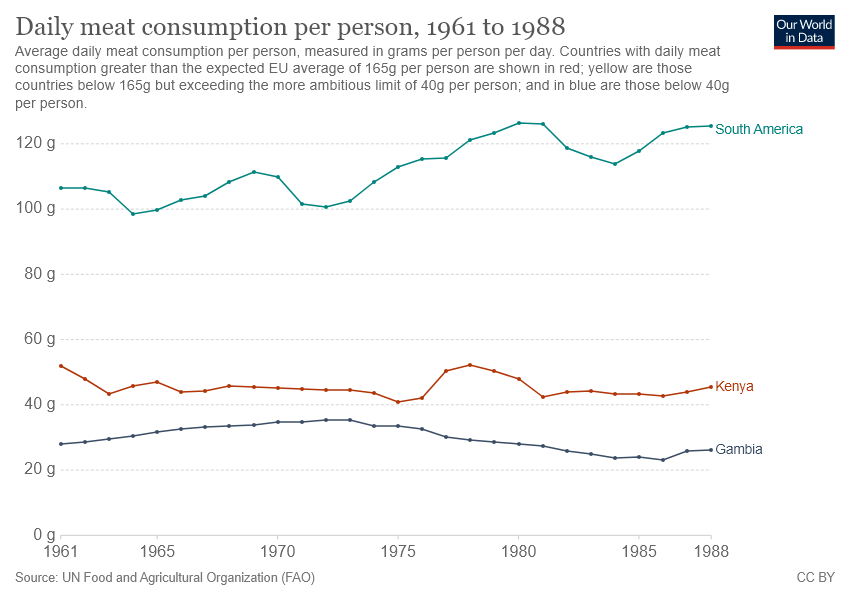Indicate a few pertinent items in this graphic. What is red data in Kenya? The data has been passed for 120 gigabytes in South America for approximately seven years. 